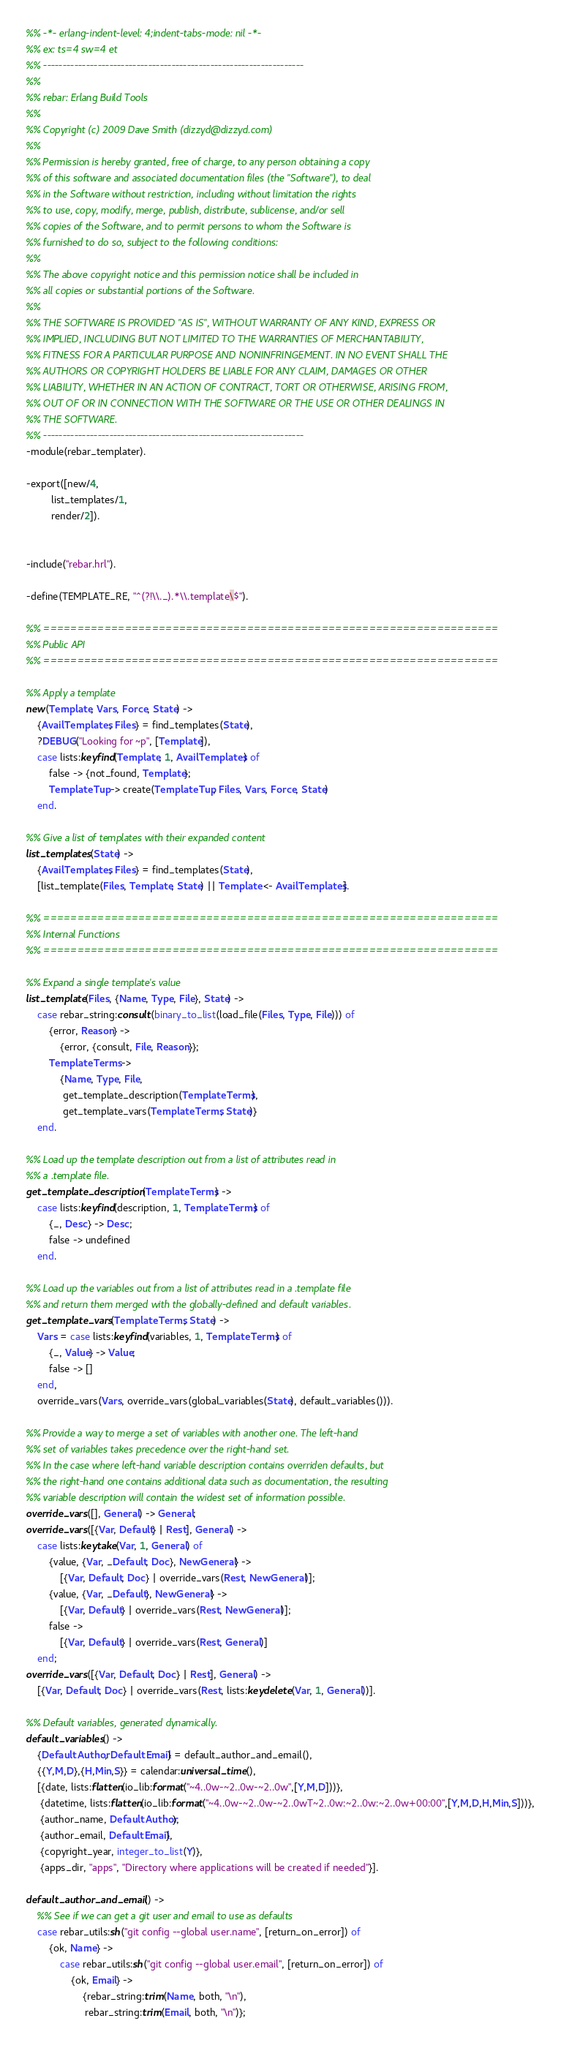Convert code to text. <code><loc_0><loc_0><loc_500><loc_500><_Erlang_>%% -*- erlang-indent-level: 4;indent-tabs-mode: nil -*-
%% ex: ts=4 sw=4 et
%% -------------------------------------------------------------------
%%
%% rebar: Erlang Build Tools
%%
%% Copyright (c) 2009 Dave Smith (dizzyd@dizzyd.com)
%%
%% Permission is hereby granted, free of charge, to any person obtaining a copy
%% of this software and associated documentation files (the "Software"), to deal
%% in the Software without restriction, including without limitation the rights
%% to use, copy, modify, merge, publish, distribute, sublicense, and/or sell
%% copies of the Software, and to permit persons to whom the Software is
%% furnished to do so, subject to the following conditions:
%%
%% The above copyright notice and this permission notice shall be included in
%% all copies or substantial portions of the Software.
%%
%% THE SOFTWARE IS PROVIDED "AS IS", WITHOUT WARRANTY OF ANY KIND, EXPRESS OR
%% IMPLIED, INCLUDING BUT NOT LIMITED TO THE WARRANTIES OF MERCHANTABILITY,
%% FITNESS FOR A PARTICULAR PURPOSE AND NONINFRINGEMENT. IN NO EVENT SHALL THE
%% AUTHORS OR COPYRIGHT HOLDERS BE LIABLE FOR ANY CLAIM, DAMAGES OR OTHER
%% LIABILITY, WHETHER IN AN ACTION OF CONTRACT, TORT OR OTHERWISE, ARISING FROM,
%% OUT OF OR IN CONNECTION WITH THE SOFTWARE OR THE USE OR OTHER DEALINGS IN
%% THE SOFTWARE.
%% -------------------------------------------------------------------
-module(rebar_templater).

-export([new/4,
         list_templates/1,
         render/2]).


-include("rebar.hrl").

-define(TEMPLATE_RE, "^(?!\\._).*\\.template\$").

%% ===================================================================
%% Public API
%% ===================================================================

%% Apply a template
new(Template, Vars, Force, State) ->
    {AvailTemplates, Files} = find_templates(State),
    ?DEBUG("Looking for ~p", [Template]),
    case lists:keyfind(Template, 1, AvailTemplates) of
        false -> {not_found, Template};
        TemplateTup -> create(TemplateTup, Files, Vars, Force, State)
    end.

%% Give a list of templates with their expanded content
list_templates(State) ->
    {AvailTemplates, Files} = find_templates(State),
    [list_template(Files, Template, State) || Template <- AvailTemplates].

%% ===================================================================
%% Internal Functions
%% ===================================================================

%% Expand a single template's value
list_template(Files, {Name, Type, File}, State) ->
    case rebar_string:consult(binary_to_list(load_file(Files, Type, File))) of
        {error, Reason} ->
            {error, {consult, File, Reason}};
        TemplateTerms ->
            {Name, Type, File,
             get_template_description(TemplateTerms),
             get_template_vars(TemplateTerms, State)}
    end.

%% Load up the template description out from a list of attributes read in
%% a .template file.
get_template_description(TemplateTerms) ->
    case lists:keyfind(description, 1, TemplateTerms) of
        {_, Desc} -> Desc;
        false -> undefined
    end.

%% Load up the variables out from a list of attributes read in a .template file
%% and return them merged with the globally-defined and default variables.
get_template_vars(TemplateTerms, State) ->
    Vars = case lists:keyfind(variables, 1, TemplateTerms) of
        {_, Value} -> Value;
        false -> []
    end,
    override_vars(Vars, override_vars(global_variables(State), default_variables())).

%% Provide a way to merge a set of variables with another one. The left-hand
%% set of variables takes precedence over the right-hand set.
%% In the case where left-hand variable description contains overriden defaults, but
%% the right-hand one contains additional data such as documentation, the resulting
%% variable description will contain the widest set of information possible.
override_vars([], General) -> General;
override_vars([{Var, Default} | Rest], General) ->
    case lists:keytake(Var, 1, General) of
        {value, {Var, _Default, Doc}, NewGeneral} ->
            [{Var, Default, Doc} | override_vars(Rest, NewGeneral)];
        {value, {Var, _Default}, NewGeneral} ->
            [{Var, Default} | override_vars(Rest, NewGeneral)];
        false ->
            [{Var, Default} | override_vars(Rest, General)]
    end;
override_vars([{Var, Default, Doc} | Rest], General) ->
    [{Var, Default, Doc} | override_vars(Rest, lists:keydelete(Var, 1, General))].

%% Default variables, generated dynamically.
default_variables() ->
    {DefaultAuthor, DefaultEmail} = default_author_and_email(),
    {{Y,M,D},{H,Min,S}} = calendar:universal_time(),
    [{date, lists:flatten(io_lib:format("~4..0w-~2..0w-~2..0w",[Y,M,D]))},
     {datetime, lists:flatten(io_lib:format("~4..0w-~2..0w-~2..0wT~2..0w:~2..0w:~2..0w+00:00",[Y,M,D,H,Min,S]))},
     {author_name, DefaultAuthor},
     {author_email, DefaultEmail},
     {copyright_year, integer_to_list(Y)},
     {apps_dir, "apps", "Directory where applications will be created if needed"}].

default_author_and_email() ->
    %% See if we can get a git user and email to use as defaults
    case rebar_utils:sh("git config --global user.name", [return_on_error]) of
        {ok, Name} ->
            case rebar_utils:sh("git config --global user.email", [return_on_error]) of
                {ok, Email} ->
                    {rebar_string:trim(Name, both, "\n"),
                     rebar_string:trim(Email, both, "\n")};</code> 